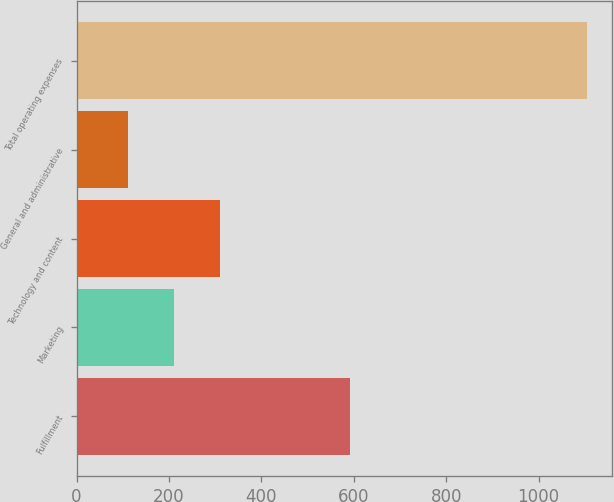<chart> <loc_0><loc_0><loc_500><loc_500><bar_chart><fcel>Fulfillment<fcel>Marketing<fcel>Technology and content<fcel>General and administrative<fcel>Total operating expenses<nl><fcel>591<fcel>211.2<fcel>310.4<fcel>112<fcel>1104<nl></chart> 